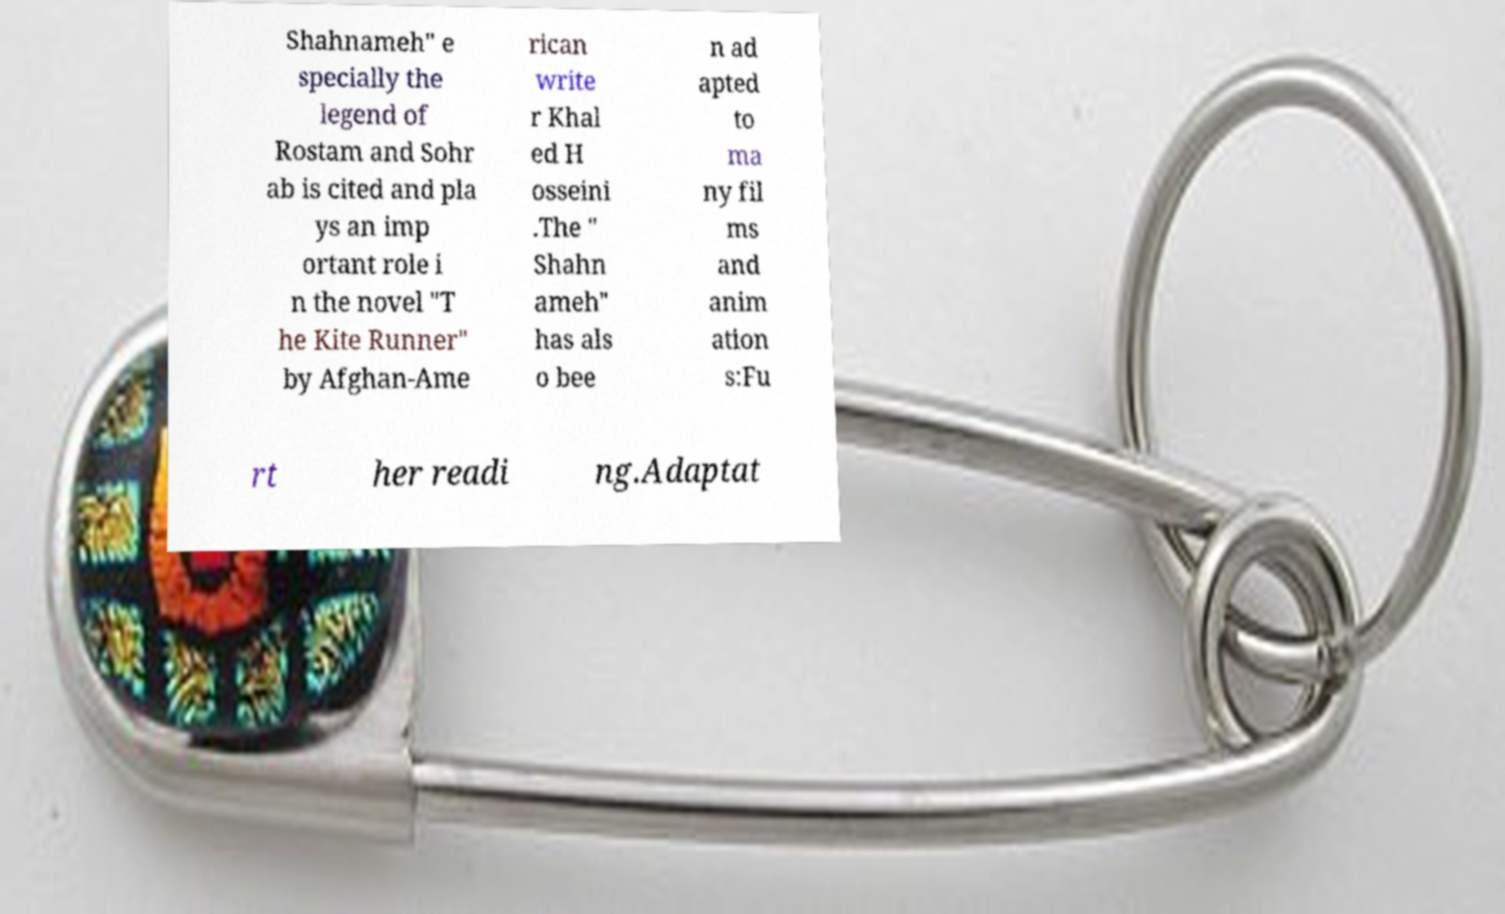Can you read and provide the text displayed in the image?This photo seems to have some interesting text. Can you extract and type it out for me? Shahnameh" e specially the legend of Rostam and Sohr ab is cited and pla ys an imp ortant role i n the novel "T he Kite Runner" by Afghan-Ame rican write r Khal ed H osseini .The " Shahn ameh" has als o bee n ad apted to ma ny fil ms and anim ation s:Fu rt her readi ng.Adaptat 